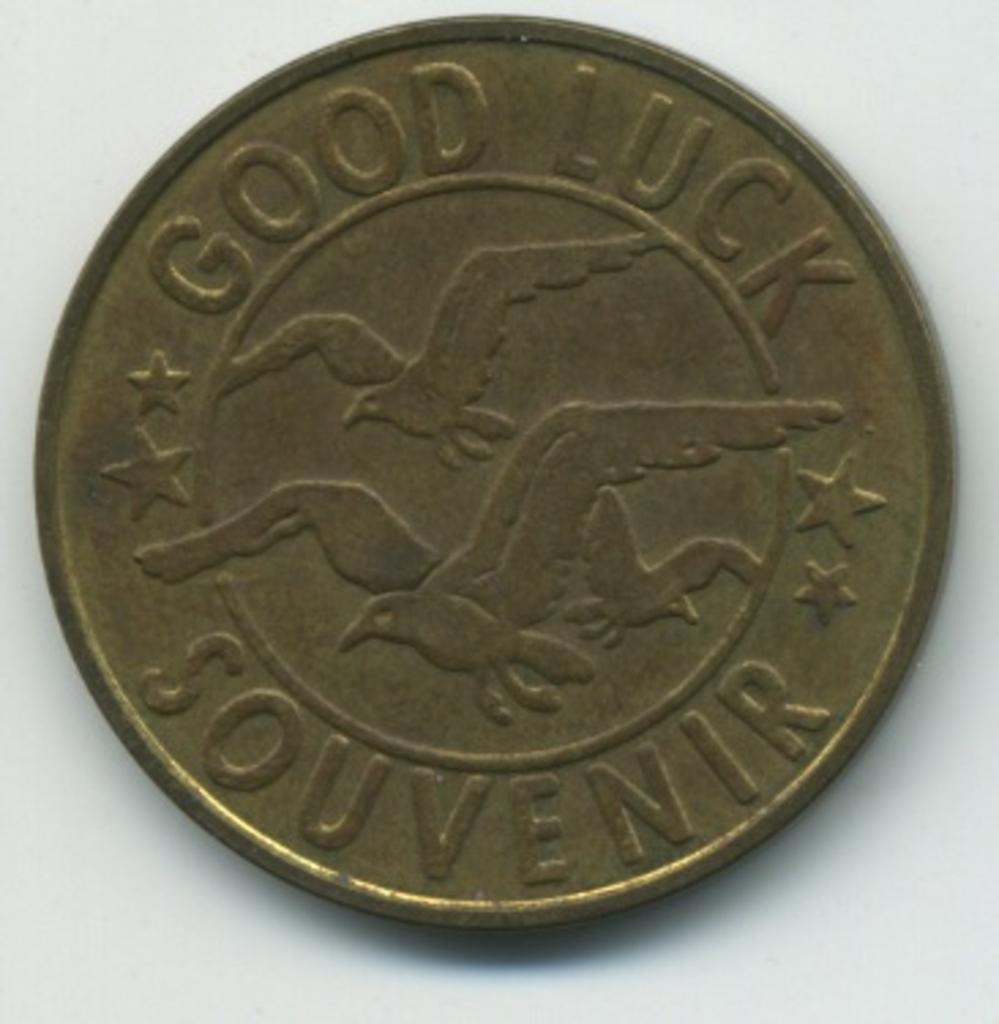Provide a one-sentence caption for the provided image. An old silver coin with three birds in the center and Good Luck Souvenir written on the outer part. 